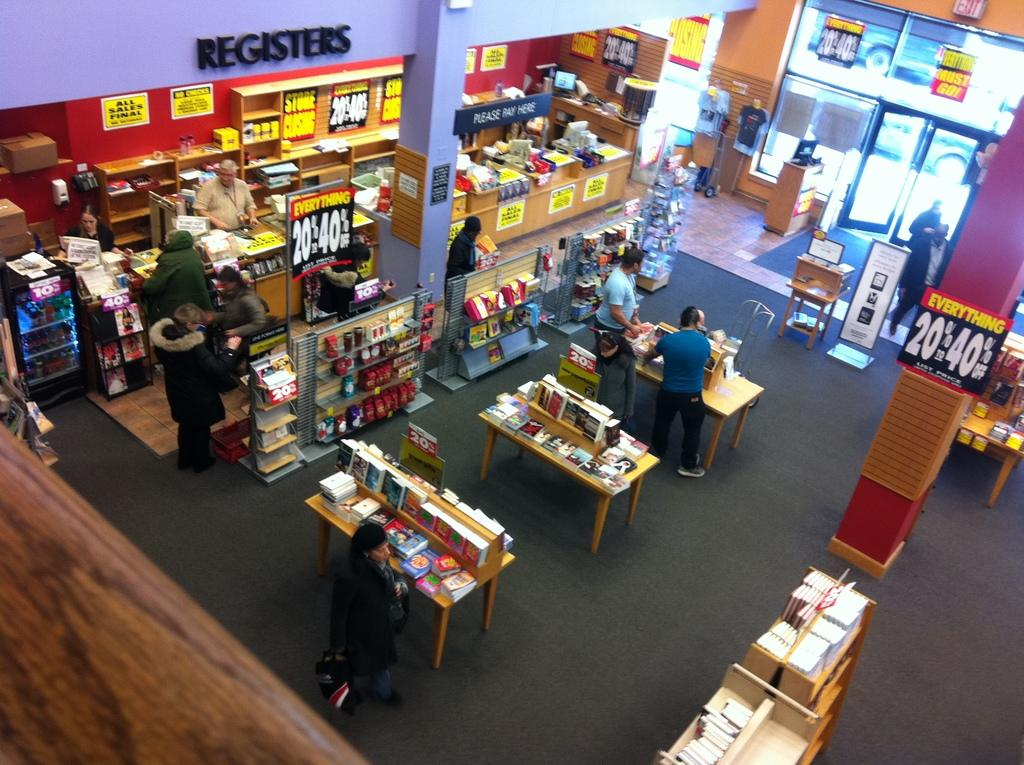<image>
Relay a brief, clear account of the picture shown. An ariel view of the interior of a bookstore where everything is 20% - 40% off. 